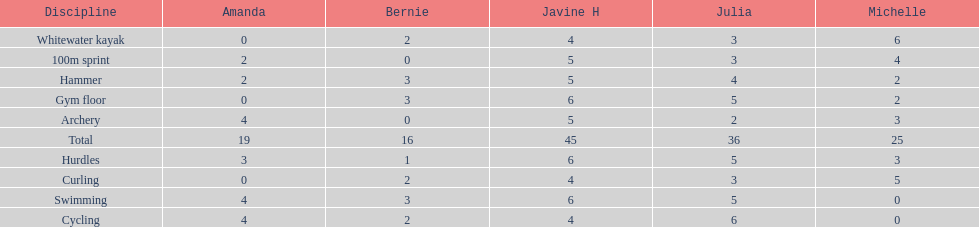Who scored the least on whitewater kayak? Amanda. 